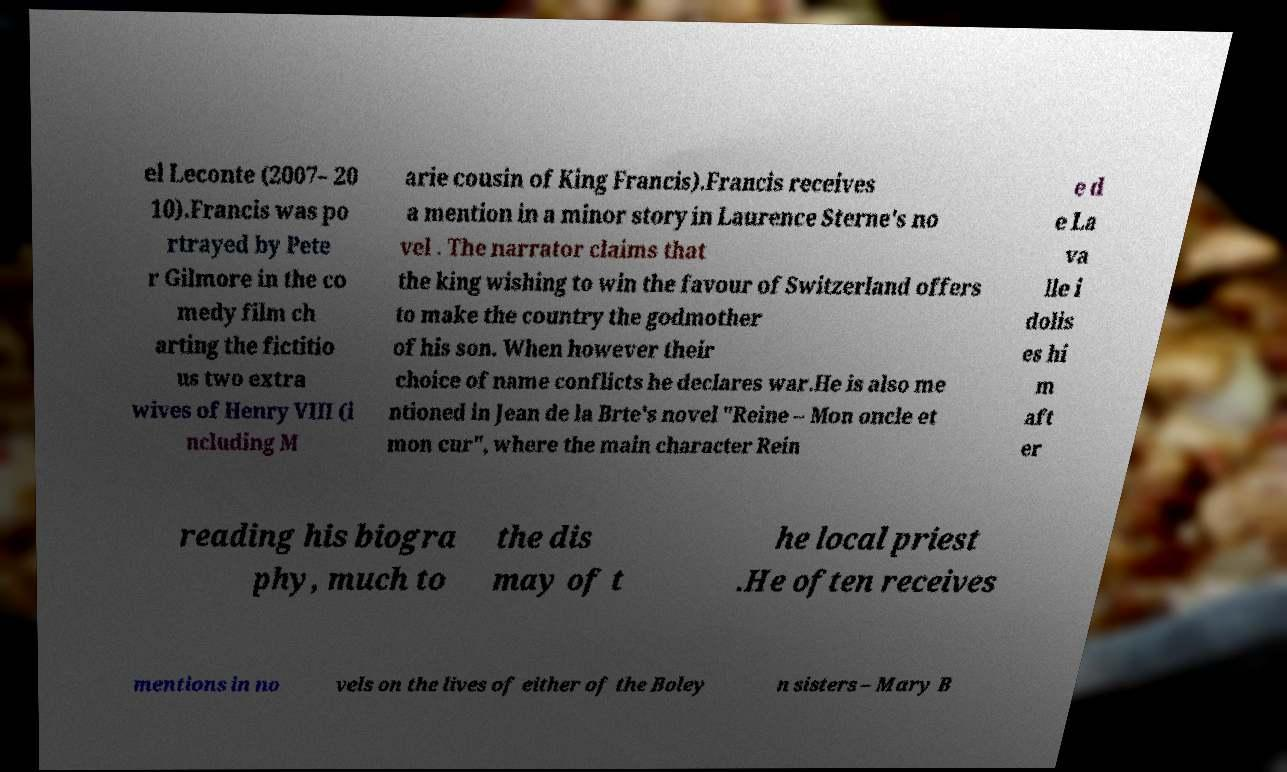I need the written content from this picture converted into text. Can you do that? el Leconte (2007– 20 10).Francis was po rtrayed by Pete r Gilmore in the co medy film ch arting the fictitio us two extra wives of Henry VIII (i ncluding M arie cousin of King Francis).Francis receives a mention in a minor story in Laurence Sterne's no vel . The narrator claims that the king wishing to win the favour of Switzerland offers to make the country the godmother of his son. When however their choice of name conflicts he declares war.He is also me ntioned in Jean de la Brte's novel "Reine – Mon oncle et mon cur", where the main character Rein e d e La va lle i dolis es hi m aft er reading his biogra phy, much to the dis may of t he local priest .He often receives mentions in no vels on the lives of either of the Boley n sisters – Mary B 